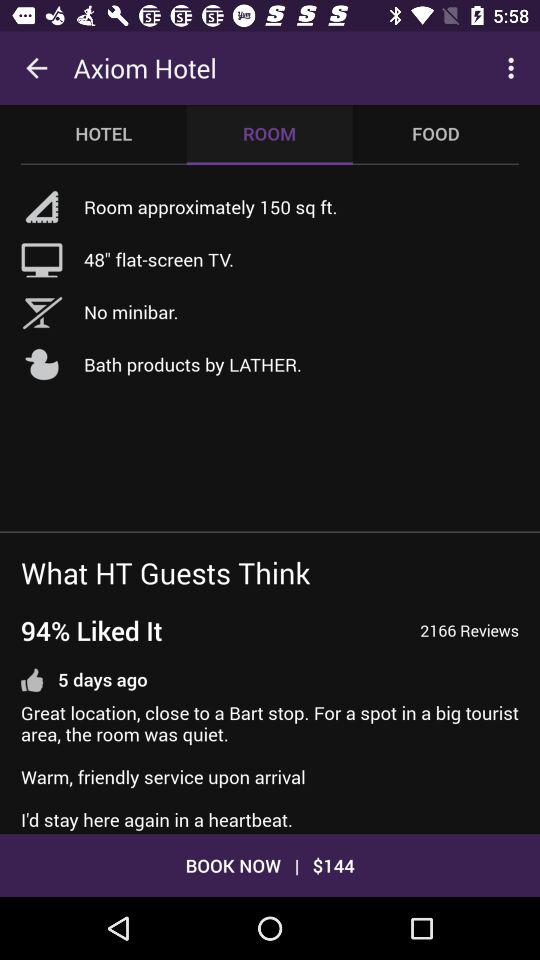What is the brand name of the bath products? The brand name is "LATHER". 